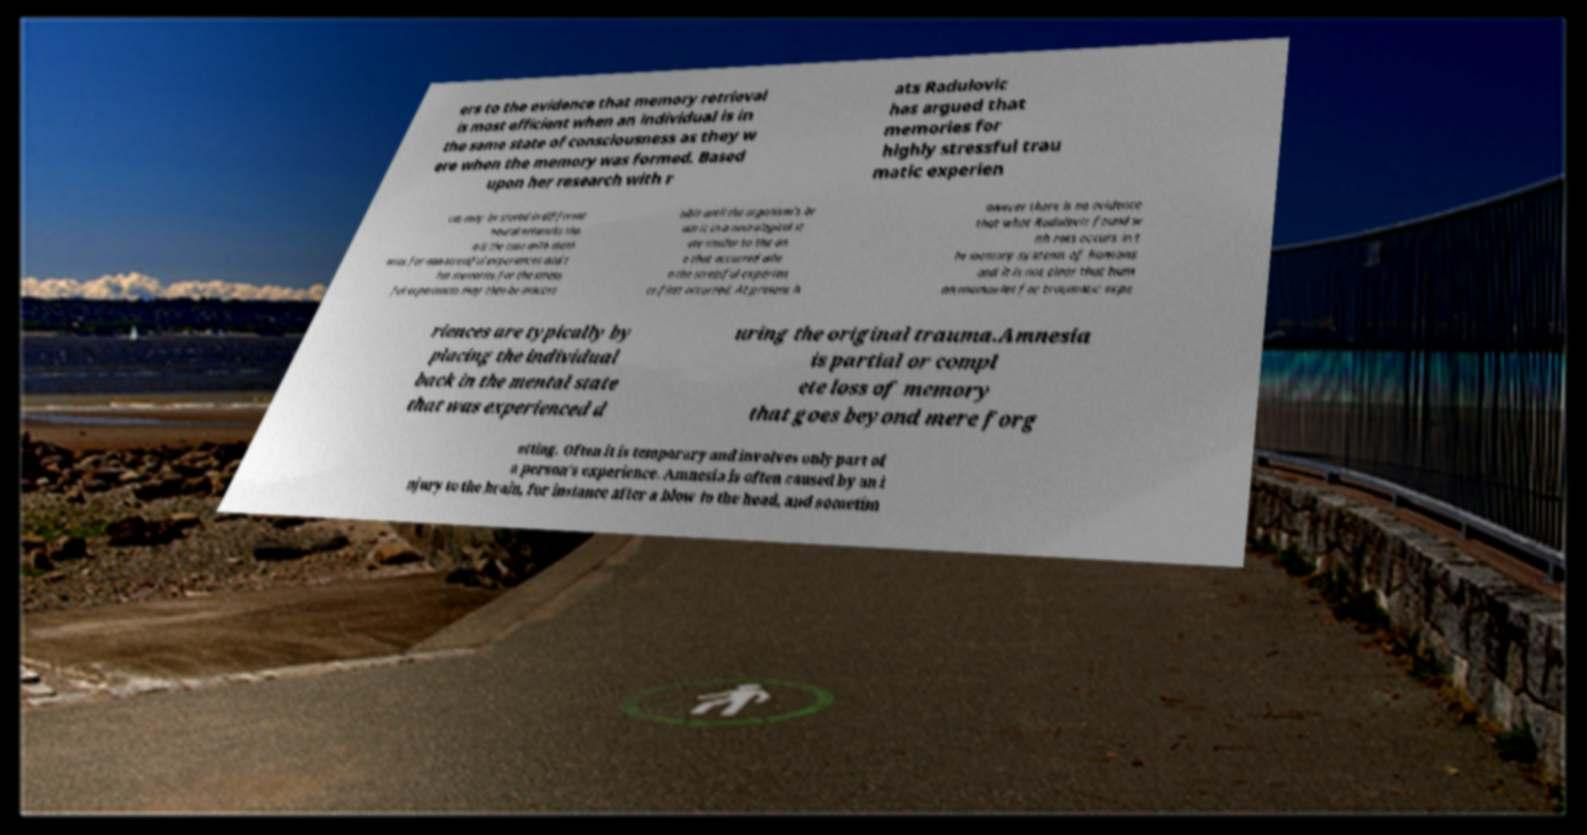Please read and relay the text visible in this image. What does it say? ers to the evidence that memory retrieval is most efficient when an individual is in the same state of consciousness as they w ere when the memory was formed. Based upon her research with r ats Radulovic has argued that memories for highly stressful trau matic experien ces may be stored in different neural networks tha n is the case with mem ories for non-stressful experiences and t hat memories for the stress ful experiences may then be inacces sible until the organism's br ain is in a neurological st ate similar to the on e that occurred whe n the stressful experien ce first occurred. At present h owever there is no evidence that what Radulovic found w ith rats occurs in t he memory systems of humans and it is not clear that hum an memories for traumatic expe riences are typically by placing the individual back in the mental state that was experienced d uring the original trauma.Amnesia is partial or compl ete loss of memory that goes beyond mere forg etting. Often it is temporary and involves only part of a person's experience. Amnesia is often caused by an i njury to the brain, for instance after a blow to the head, and sometim 